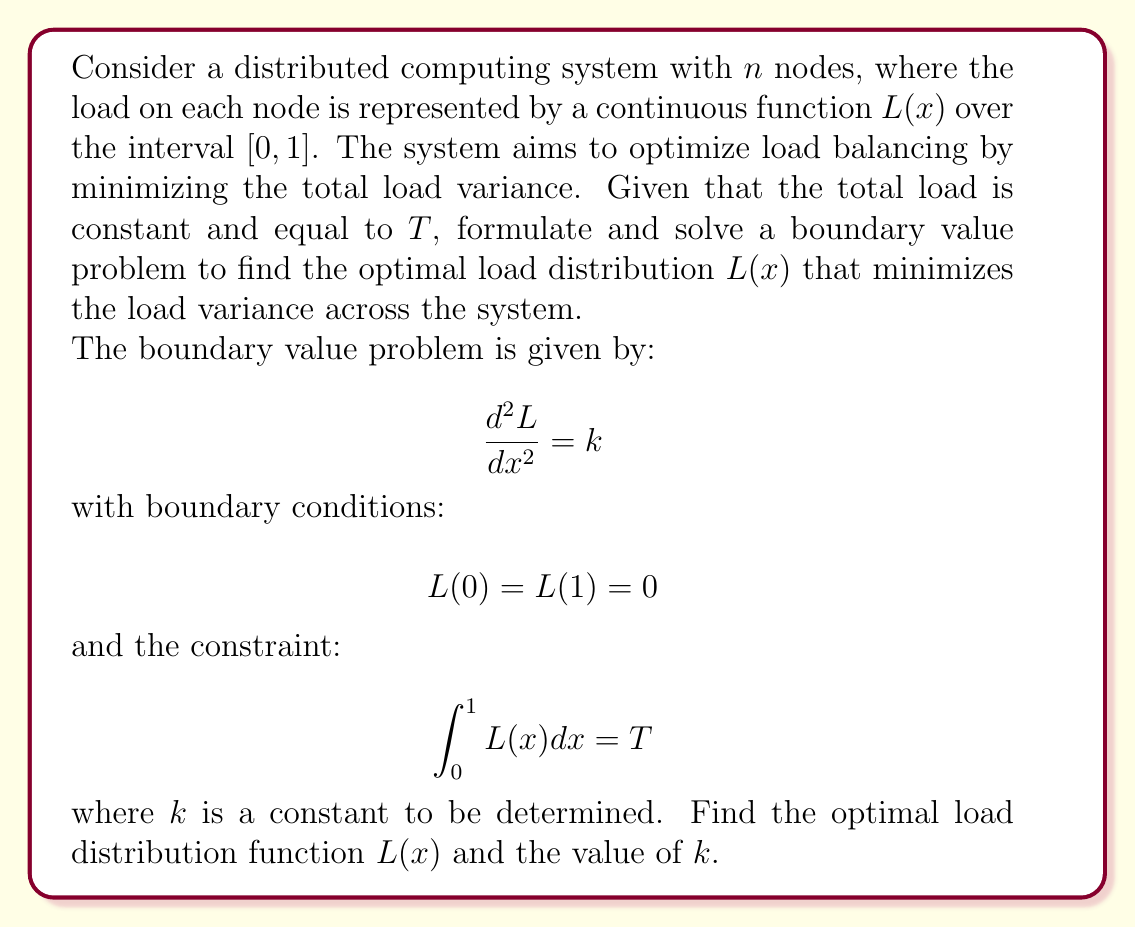Teach me how to tackle this problem. To solve this boundary value problem and optimize load balancing in a distributed computing environment, we'll follow these steps:

1. Solve the differential equation:
The general solution to $\frac{d^2L}{dx^2} = k$ is:

$$L(x) = \frac{k}{2}x^2 + Ax + B$$

where $A$ and $B$ are constants to be determined.

2. Apply the boundary conditions:
$L(0) = 0$ implies $B = 0$
$L(1) = 0$ implies $\frac{k}{2} + A = 0$, so $A = -\frac{k}{2}$

Therefore, the load distribution function is:

$$L(x) = \frac{k}{2}x^2 - \frac{k}{2}x$$

3. Apply the constraint:
$$\int_0^1 L(x) dx = T$$

$$\int_0^1 (\frac{k}{2}x^2 - \frac{k}{2}x) dx = T$$

$$[\frac{k}{6}x^3 - \frac{k}{4}x^2]_0^1 = T$$

$$\frac{k}{6} - \frac{k}{4} = T$$

$$-\frac{k}{12} = T$$

4. Solve for $k$:
$$k = -12T$$

5. Substitute $k$ back into the load distribution function:
$$L(x) = -6Tx^2 + 6Tx$$

This function represents the optimal load distribution that minimizes the load variance across the distributed computing system.
Answer: The optimal load distribution function is:

$$L(x) = 6T(x - x^2)$$

where $T$ is the total load of the system.

The value of the constant $k$ is:

$$k = -12T$$ 